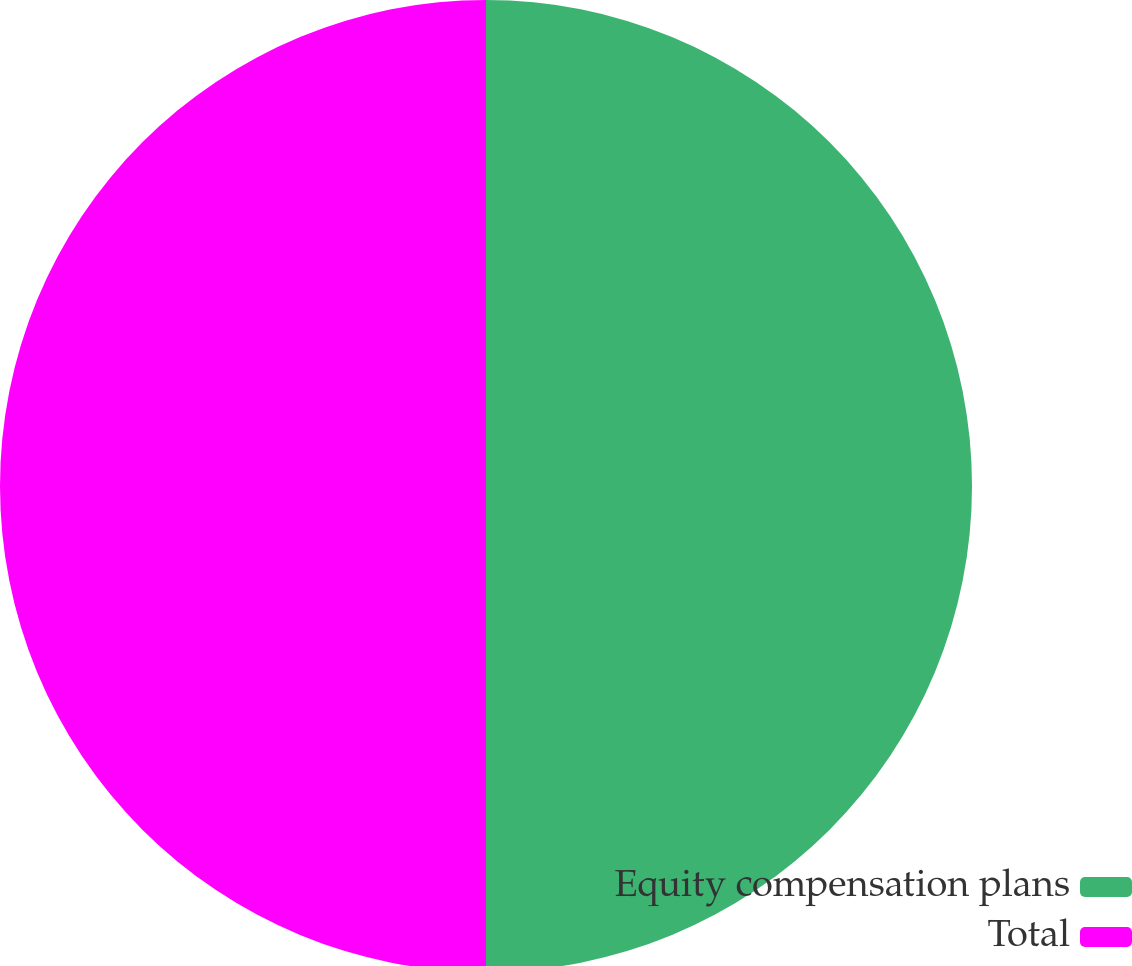<chart> <loc_0><loc_0><loc_500><loc_500><pie_chart><fcel>Equity compensation plans<fcel>Total<nl><fcel>50.0%<fcel>50.0%<nl></chart> 